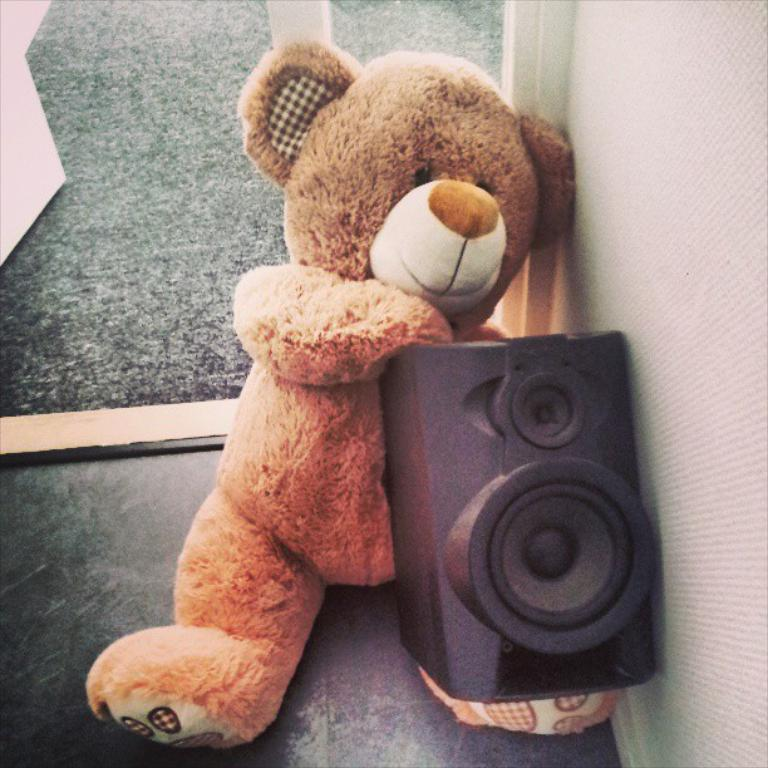What type of object can be seen in the image? There is a teddy bear in the image. What other object is present in the image? There is a speaker in the image. What part of the room is visible at the bottom of the image? The floor is visible at the bottom of the image. What can be seen on the right side of the image? There is a wall to the right side of the image. How does the teddy bear jump in the image? The teddy bear does not jump in the image; it is an inanimate object and cannot perform actions like jumping. 